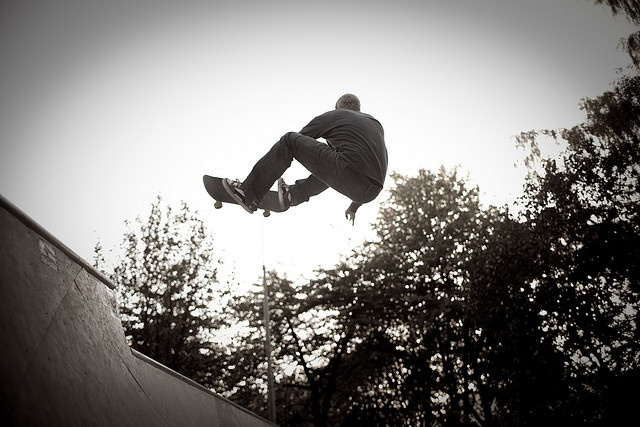Describe the objects in this image and their specific colors. I can see people in black, gray, and white tones and skateboard in black and gray tones in this image. 